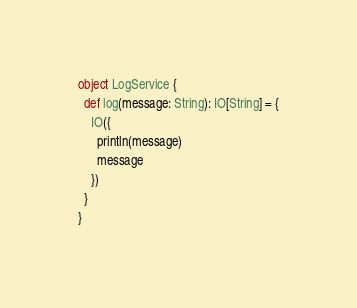Convert code to text. <code><loc_0><loc_0><loc_500><loc_500><_Scala_>
object LogService {
  def log(message: String): IO[String] = {
    IO({
      println(message)
      message
    })
  }
}
</code> 